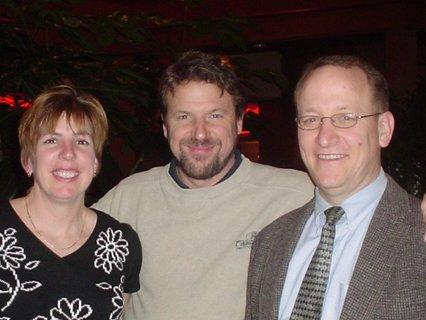Based on the information provided, infer the possible occasion or event these people might be attending. The people might be attending a formal event or gathering as they are dressed in suits, ties, and elegant clothing with jewelry. Describe the types of eyewear the people in the image are wearing or holding, if any. There are two instances of eyeglasses in the image: one man is wearing thin glasses, and another pair of eyeglasses appears floating with a bounding box. Identify the number of people in the image and their appearances. There are three people in the image: a man wearing glasses and a grey suit with a tie, a man wearing a light-colored shirt with facial hair, and a woman with blonde hair wearing a black shirt, earrings, and a gold necklace. What type of jewelry is seen on the woman in this picture? The woman is wearing a gold necklace and earrings. What are the prominent clothing patterns seen in the image among the subjects? Prominent clothing patterns are a black and white shirt with flower petals and a floral pattern on a woman's shirt. Can you spot any object mentioned in the image that appears to be out of place or doesn't fit in the scene? A red glow behind the man wearing a suit seems out of place in the scene. Count how many instances of flower petals on the black and white shirt can be found. There are 10 instances of flower petals on the black and white shirt. What is the primary setting of this image and point out the background elements. The primary setting of the image is a gathering of three people with a background featuring red lights, green leaves on a tree, and plants hanging. Briefly describe the hair and facial appearances of the people in the image. The man in the suit has brown hair and a receding hairline. The man in the light-colored shirt has facial hair, a dark goatee, and a beard. The woman has blonde hair and a bright smile. 